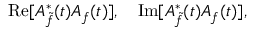<formula> <loc_0><loc_0><loc_500><loc_500>R e [ A _ { \tilde { f } } ^ { \ast } ( t ) A _ { f } ( t ) ] , \quad I m [ A _ { \tilde { f } } ^ { \ast } ( t ) A _ { f } ( t ) ] ,</formula> 